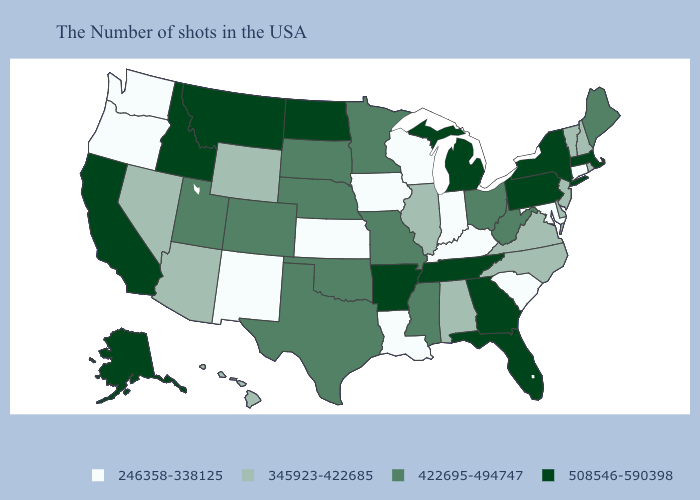Does Washington have the same value as Oregon?
Quick response, please. Yes. Name the states that have a value in the range 508546-590398?
Keep it brief. Massachusetts, New York, Pennsylvania, Florida, Georgia, Michigan, Tennessee, Arkansas, North Dakota, Montana, Idaho, California, Alaska. What is the lowest value in the West?
Keep it brief. 246358-338125. What is the highest value in the USA?
Quick response, please. 508546-590398. What is the value of New Hampshire?
Give a very brief answer. 345923-422685. Does Iowa have the lowest value in the USA?
Short answer required. Yes. What is the highest value in the Northeast ?
Give a very brief answer. 508546-590398. Does Florida have the highest value in the USA?
Keep it brief. Yes. What is the lowest value in the USA?
Concise answer only. 246358-338125. What is the value of Wisconsin?
Answer briefly. 246358-338125. Among the states that border Oregon , does Nevada have the lowest value?
Quick response, please. No. Among the states that border Wisconsin , does Illinois have the highest value?
Short answer required. No. Name the states that have a value in the range 345923-422685?
Be succinct. Rhode Island, New Hampshire, Vermont, New Jersey, Delaware, Virginia, North Carolina, Alabama, Illinois, Wyoming, Arizona, Nevada, Hawaii. What is the value of Rhode Island?
Concise answer only. 345923-422685. Which states hav the highest value in the South?
Keep it brief. Florida, Georgia, Tennessee, Arkansas. 